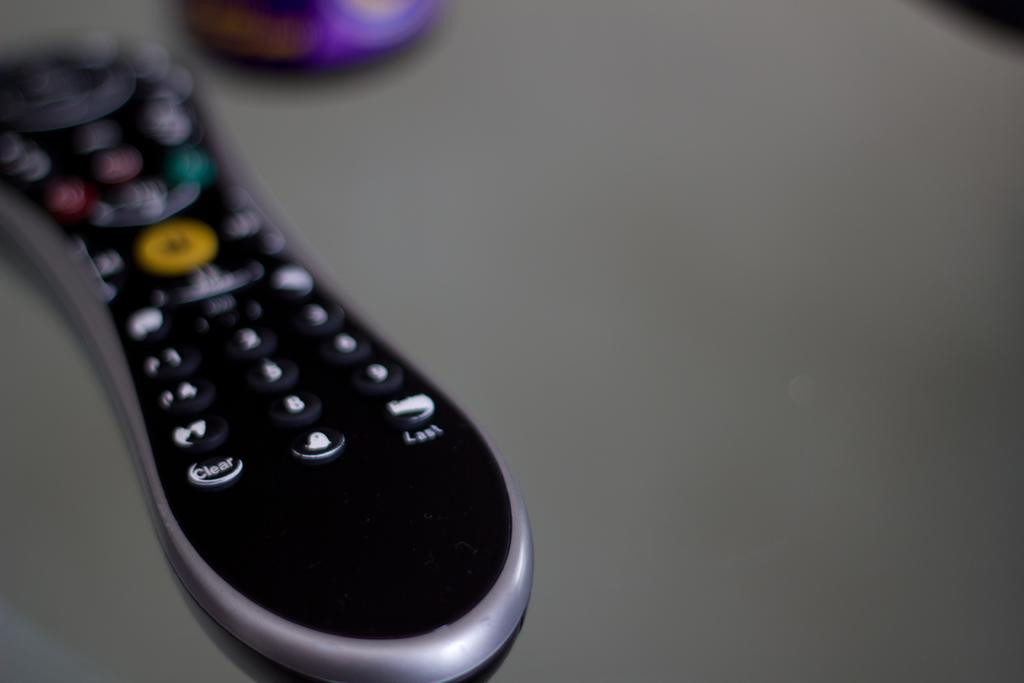<image>
Share a concise interpretation of the image provided. close up of silver and black remote with clear and last buttons visible 